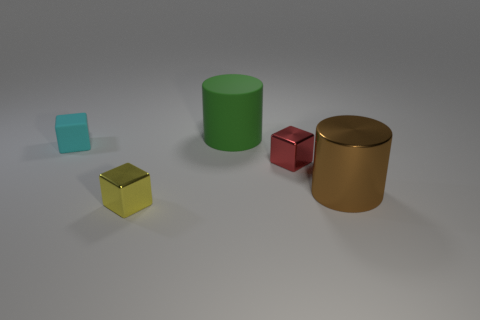Are there any other things that are the same shape as the large green thing?
Your response must be concise. Yes. What material is the object that is on the left side of the yellow metal thing?
Your response must be concise. Rubber. What is the size of the other metal thing that is the same shape as the yellow metal object?
Offer a terse response. Small. What number of cylinders are made of the same material as the tiny red cube?
Ensure brevity in your answer.  1. What number of things are either metal objects that are to the right of the yellow metal cube or metallic blocks right of the green rubber object?
Your response must be concise. 2. Are there fewer big objects that are on the left side of the big matte object than large matte things?
Offer a very short reply. Yes. Are there any cylinders of the same size as the brown thing?
Provide a succinct answer. Yes. The small rubber block is what color?
Provide a succinct answer. Cyan. Is the size of the cyan thing the same as the red cube?
Make the answer very short. Yes. How many objects are yellow shiny objects or large shiny things?
Provide a succinct answer. 2. 